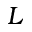Convert formula to latex. <formula><loc_0><loc_0><loc_500><loc_500>L</formula> 